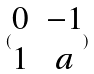<formula> <loc_0><loc_0><loc_500><loc_500>( \begin{matrix} 0 & - 1 \\ 1 & a \\ \end{matrix} )</formula> 